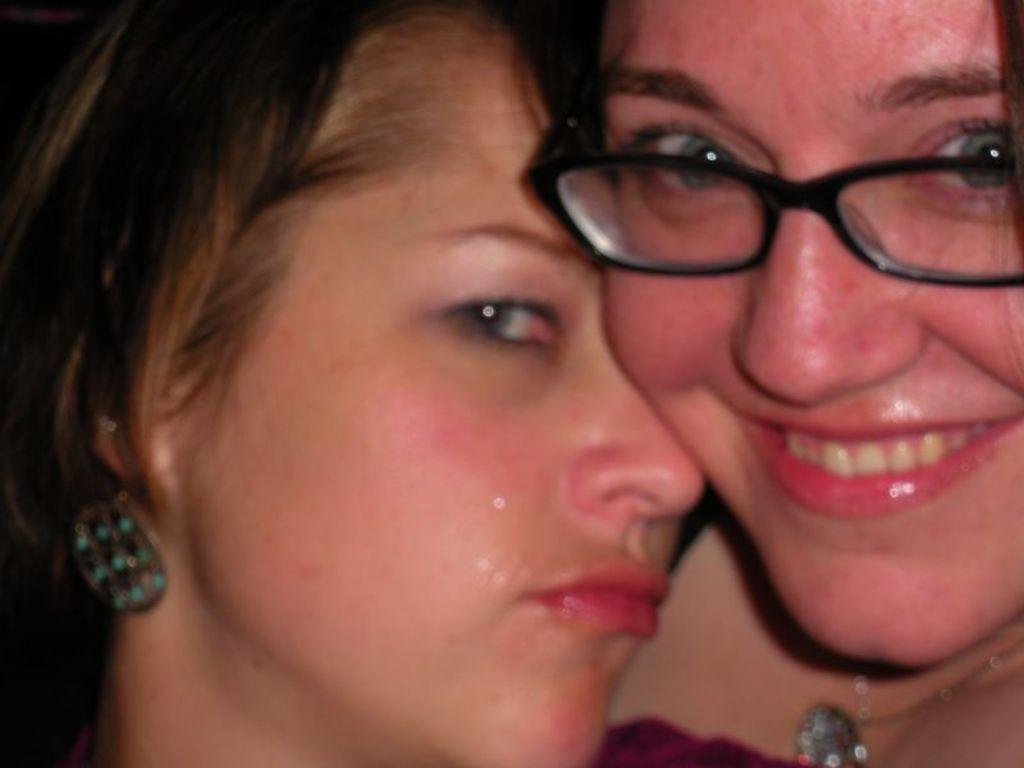Who is on the left side of the image? There is a girl on the left side of the image. Who is on the right side of the image? There is a woman on the right side of the image. What is the woman wearing? The woman is wearing spectacles. What expression does the woman have? The woman is smiling. What type of pets are visible in the image? There are no pets visible in the image. Can you tell me how many basketballs are being held by the girl in the image? There are no basketballs present in the image. 